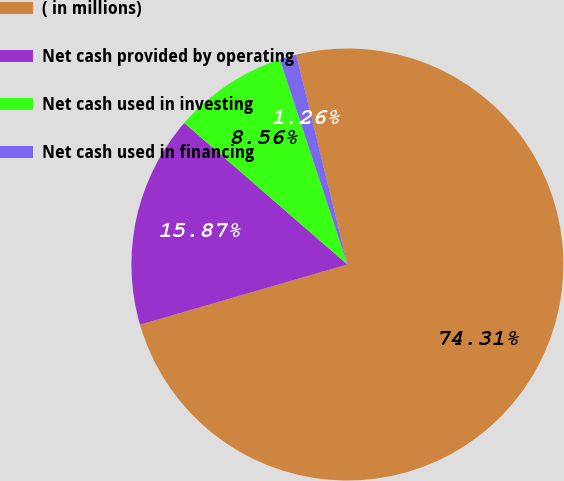Convert chart to OTSL. <chart><loc_0><loc_0><loc_500><loc_500><pie_chart><fcel>( in millions)<fcel>Net cash provided by operating<fcel>Net cash used in investing<fcel>Net cash used in financing<nl><fcel>74.31%<fcel>15.87%<fcel>8.56%<fcel>1.26%<nl></chart> 